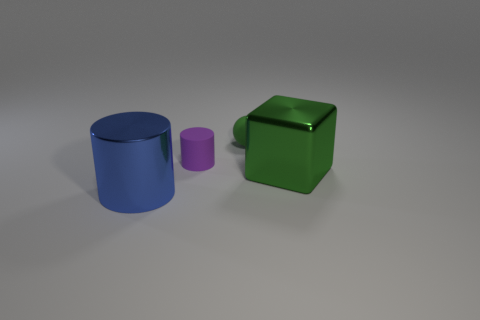Add 3 big cyan objects. How many objects exist? 7 Subtract all cubes. How many objects are left? 3 Add 4 spheres. How many spheres are left? 5 Add 3 green balls. How many green balls exist? 4 Subtract 1 blue cylinders. How many objects are left? 3 Subtract all yellow blocks. Subtract all big green things. How many objects are left? 3 